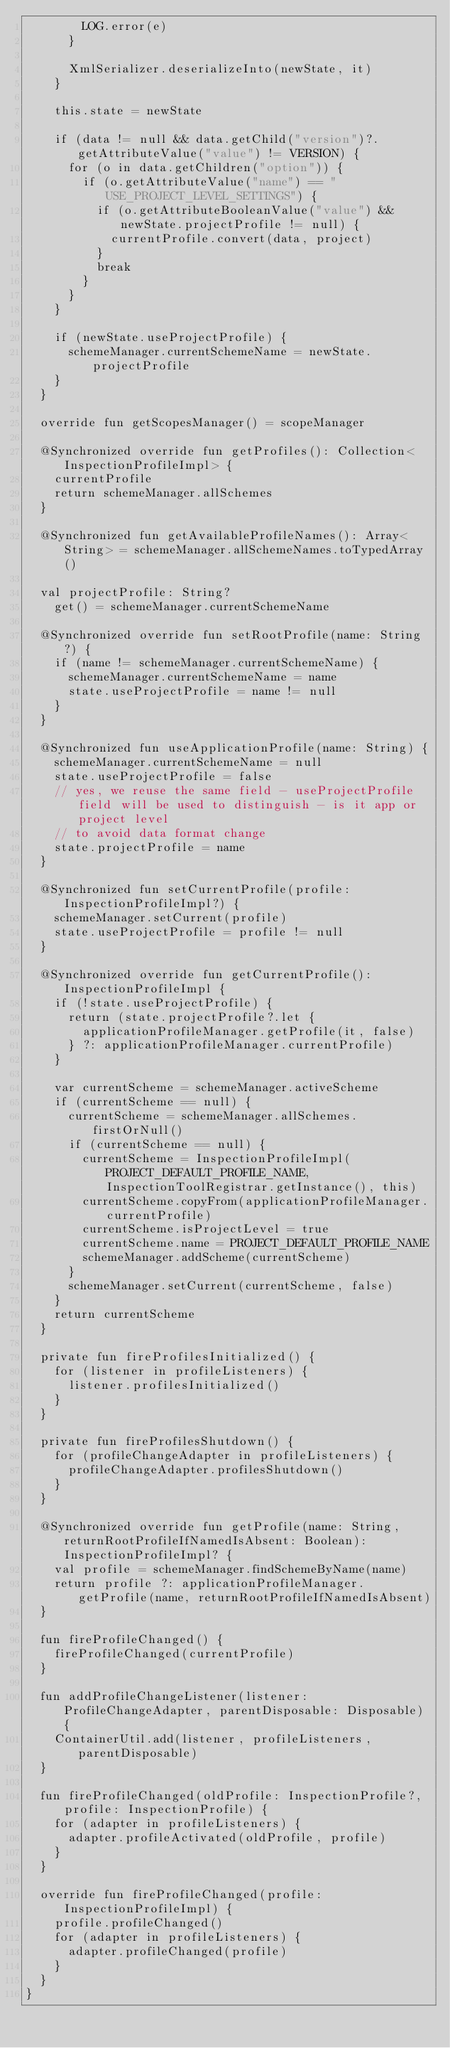Convert code to text. <code><loc_0><loc_0><loc_500><loc_500><_Kotlin_>        LOG.error(e)
      }

      XmlSerializer.deserializeInto(newState, it)
    }

    this.state = newState

    if (data != null && data.getChild("version")?.getAttributeValue("value") != VERSION) {
      for (o in data.getChildren("option")) {
        if (o.getAttributeValue("name") == "USE_PROJECT_LEVEL_SETTINGS") {
          if (o.getAttributeBooleanValue("value") && newState.projectProfile != null) {
            currentProfile.convert(data, project)
          }
          break
        }
      }
    }

    if (newState.useProjectProfile) {
      schemeManager.currentSchemeName = newState.projectProfile
    }
  }

  override fun getScopesManager() = scopeManager

  @Synchronized override fun getProfiles(): Collection<InspectionProfileImpl> {
    currentProfile
    return schemeManager.allSchemes
  }

  @Synchronized fun getAvailableProfileNames(): Array<String> = schemeManager.allSchemeNames.toTypedArray()

  val projectProfile: String?
    get() = schemeManager.currentSchemeName

  @Synchronized override fun setRootProfile(name: String?) {
    if (name != schemeManager.currentSchemeName) {
      schemeManager.currentSchemeName = name
      state.useProjectProfile = name != null
    }
  }

  @Synchronized fun useApplicationProfile(name: String) {
    schemeManager.currentSchemeName = null
    state.useProjectProfile = false
    // yes, we reuse the same field - useProjectProfile field will be used to distinguish - is it app or project level
    // to avoid data format change
    state.projectProfile = name
  }

  @Synchronized fun setCurrentProfile(profile: InspectionProfileImpl?) {
    schemeManager.setCurrent(profile)
    state.useProjectProfile = profile != null
  }

  @Synchronized override fun getCurrentProfile(): InspectionProfileImpl {
    if (!state.useProjectProfile) {
      return (state.projectProfile?.let {
        applicationProfileManager.getProfile(it, false)
      } ?: applicationProfileManager.currentProfile)
    }

    var currentScheme = schemeManager.activeScheme
    if (currentScheme == null) {
      currentScheme = schemeManager.allSchemes.firstOrNull()
      if (currentScheme == null) {
        currentScheme = InspectionProfileImpl(PROJECT_DEFAULT_PROFILE_NAME, InspectionToolRegistrar.getInstance(), this)
        currentScheme.copyFrom(applicationProfileManager.currentProfile)
        currentScheme.isProjectLevel = true
        currentScheme.name = PROJECT_DEFAULT_PROFILE_NAME
        schemeManager.addScheme(currentScheme)
      }
      schemeManager.setCurrent(currentScheme, false)
    }
    return currentScheme
  }

  private fun fireProfilesInitialized() {
    for (listener in profileListeners) {
      listener.profilesInitialized()
    }
  }

  private fun fireProfilesShutdown() {
    for (profileChangeAdapter in profileListeners) {
      profileChangeAdapter.profilesShutdown()
    }
  }

  @Synchronized override fun getProfile(name: String, returnRootProfileIfNamedIsAbsent: Boolean): InspectionProfileImpl? {
    val profile = schemeManager.findSchemeByName(name)
    return profile ?: applicationProfileManager.getProfile(name, returnRootProfileIfNamedIsAbsent)
  }

  fun fireProfileChanged() {
    fireProfileChanged(currentProfile)
  }

  fun addProfileChangeListener(listener: ProfileChangeAdapter, parentDisposable: Disposable) {
    ContainerUtil.add(listener, profileListeners, parentDisposable)
  }

  fun fireProfileChanged(oldProfile: InspectionProfile?, profile: InspectionProfile) {
    for (adapter in profileListeners) {
      adapter.profileActivated(oldProfile, profile)
    }
  }

  override fun fireProfileChanged(profile: InspectionProfileImpl) {
    profile.profileChanged()
    for (adapter in profileListeners) {
      adapter.profileChanged(profile)
    }
  }
}</code> 